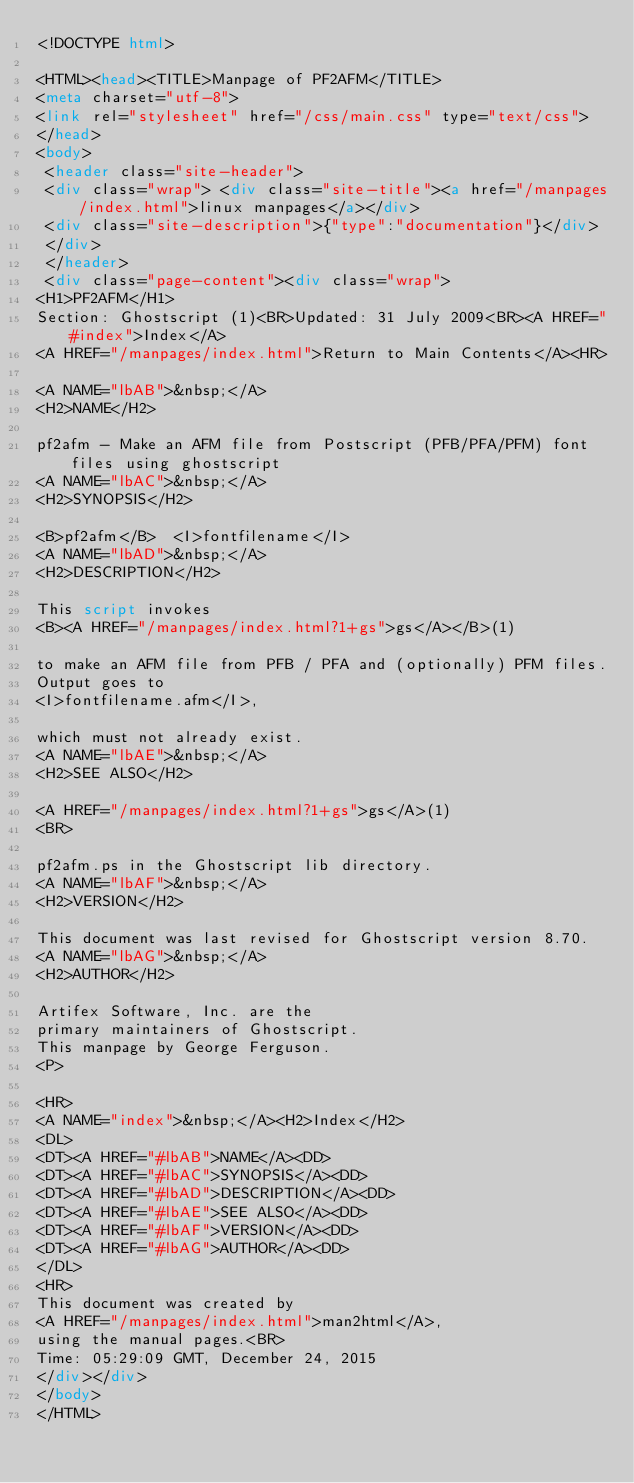<code> <loc_0><loc_0><loc_500><loc_500><_HTML_><!DOCTYPE html>

<HTML><head><TITLE>Manpage of PF2AFM</TITLE>
<meta charset="utf-8">
<link rel="stylesheet" href="/css/main.css" type="text/css">
</head>
<body>
 <header class="site-header">
 <div class="wrap"> <div class="site-title"><a href="/manpages/index.html">linux manpages</a></div>
 <div class="site-description">{"type":"documentation"}</div>
 </div>
 </header>
 <div class="page-content"><div class="wrap">
<H1>PF2AFM</H1>
Section: Ghostscript (1)<BR>Updated: 31 July 2009<BR><A HREF="#index">Index</A>
<A HREF="/manpages/index.html">Return to Main Contents</A><HR>

<A NAME="lbAB">&nbsp;</A>
<H2>NAME</H2>

pf2afm - Make an AFM file from Postscript (PFB/PFA/PFM) font files using ghostscript
<A NAME="lbAC">&nbsp;</A>
<H2>SYNOPSIS</H2>

<B>pf2afm</B>  <I>fontfilename</I>
<A NAME="lbAD">&nbsp;</A>
<H2>DESCRIPTION</H2>

This script invokes
<B><A HREF="/manpages/index.html?1+gs">gs</A></B>(1)

to make an AFM file from PFB / PFA and (optionally) PFM files.
Output goes to
<I>fontfilename.afm</I>,

which must not already exist.
<A NAME="lbAE">&nbsp;</A>
<H2>SEE ALSO</H2>

<A HREF="/manpages/index.html?1+gs">gs</A>(1)
<BR>

pf2afm.ps in the Ghostscript lib directory.
<A NAME="lbAF">&nbsp;</A>
<H2>VERSION</H2>

This document was last revised for Ghostscript version 8.70.
<A NAME="lbAG">&nbsp;</A>
<H2>AUTHOR</H2>

Artifex Software, Inc. are the
primary maintainers of Ghostscript.
This manpage by George Ferguson.
<P>

<HR>
<A NAME="index">&nbsp;</A><H2>Index</H2>
<DL>
<DT><A HREF="#lbAB">NAME</A><DD>
<DT><A HREF="#lbAC">SYNOPSIS</A><DD>
<DT><A HREF="#lbAD">DESCRIPTION</A><DD>
<DT><A HREF="#lbAE">SEE ALSO</A><DD>
<DT><A HREF="#lbAF">VERSION</A><DD>
<DT><A HREF="#lbAG">AUTHOR</A><DD>
</DL>
<HR>
This document was created by
<A HREF="/manpages/index.html">man2html</A>,
using the manual pages.<BR>
Time: 05:29:09 GMT, December 24, 2015
</div></div>
</body>
</HTML>
</code> 